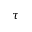<formula> <loc_0><loc_0><loc_500><loc_500>\tau</formula> 